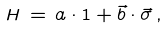<formula> <loc_0><loc_0><loc_500><loc_500>H \, = \, a \cdot 1 + \vec { b } \cdot \vec { \sigma } \, ,</formula> 